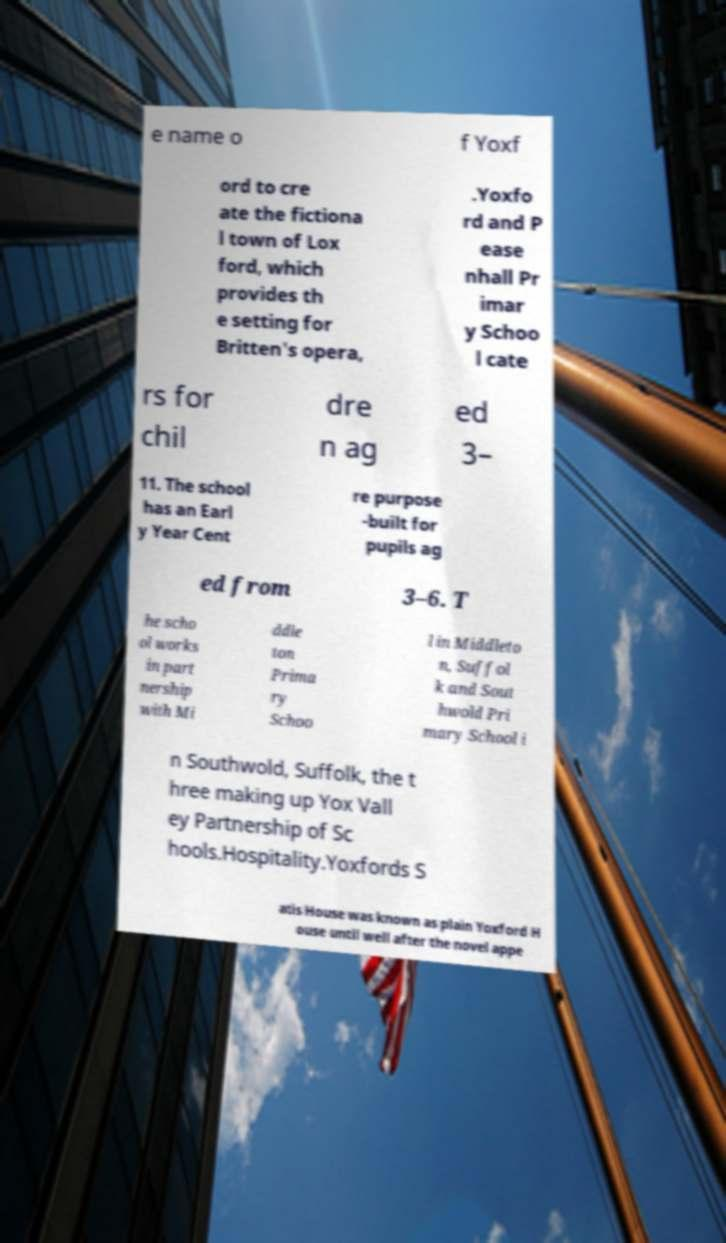Could you extract and type out the text from this image? e name o f Yoxf ord to cre ate the fictiona l town of Lox ford, which provides th e setting for Britten's opera, .Yoxfo rd and P ease nhall Pr imar y Schoo l cate rs for chil dre n ag ed 3– 11. The school has an Earl y Year Cent re purpose -built for pupils ag ed from 3–6. T he scho ol works in part nership with Mi ddle ton Prima ry Schoo l in Middleto n, Suffol k and Sout hwold Pri mary School i n Southwold, Suffolk, the t hree making up Yox Vall ey Partnership of Sc hools.Hospitality.Yoxfords S atis House was known as plain Yoxford H ouse until well after the novel appe 